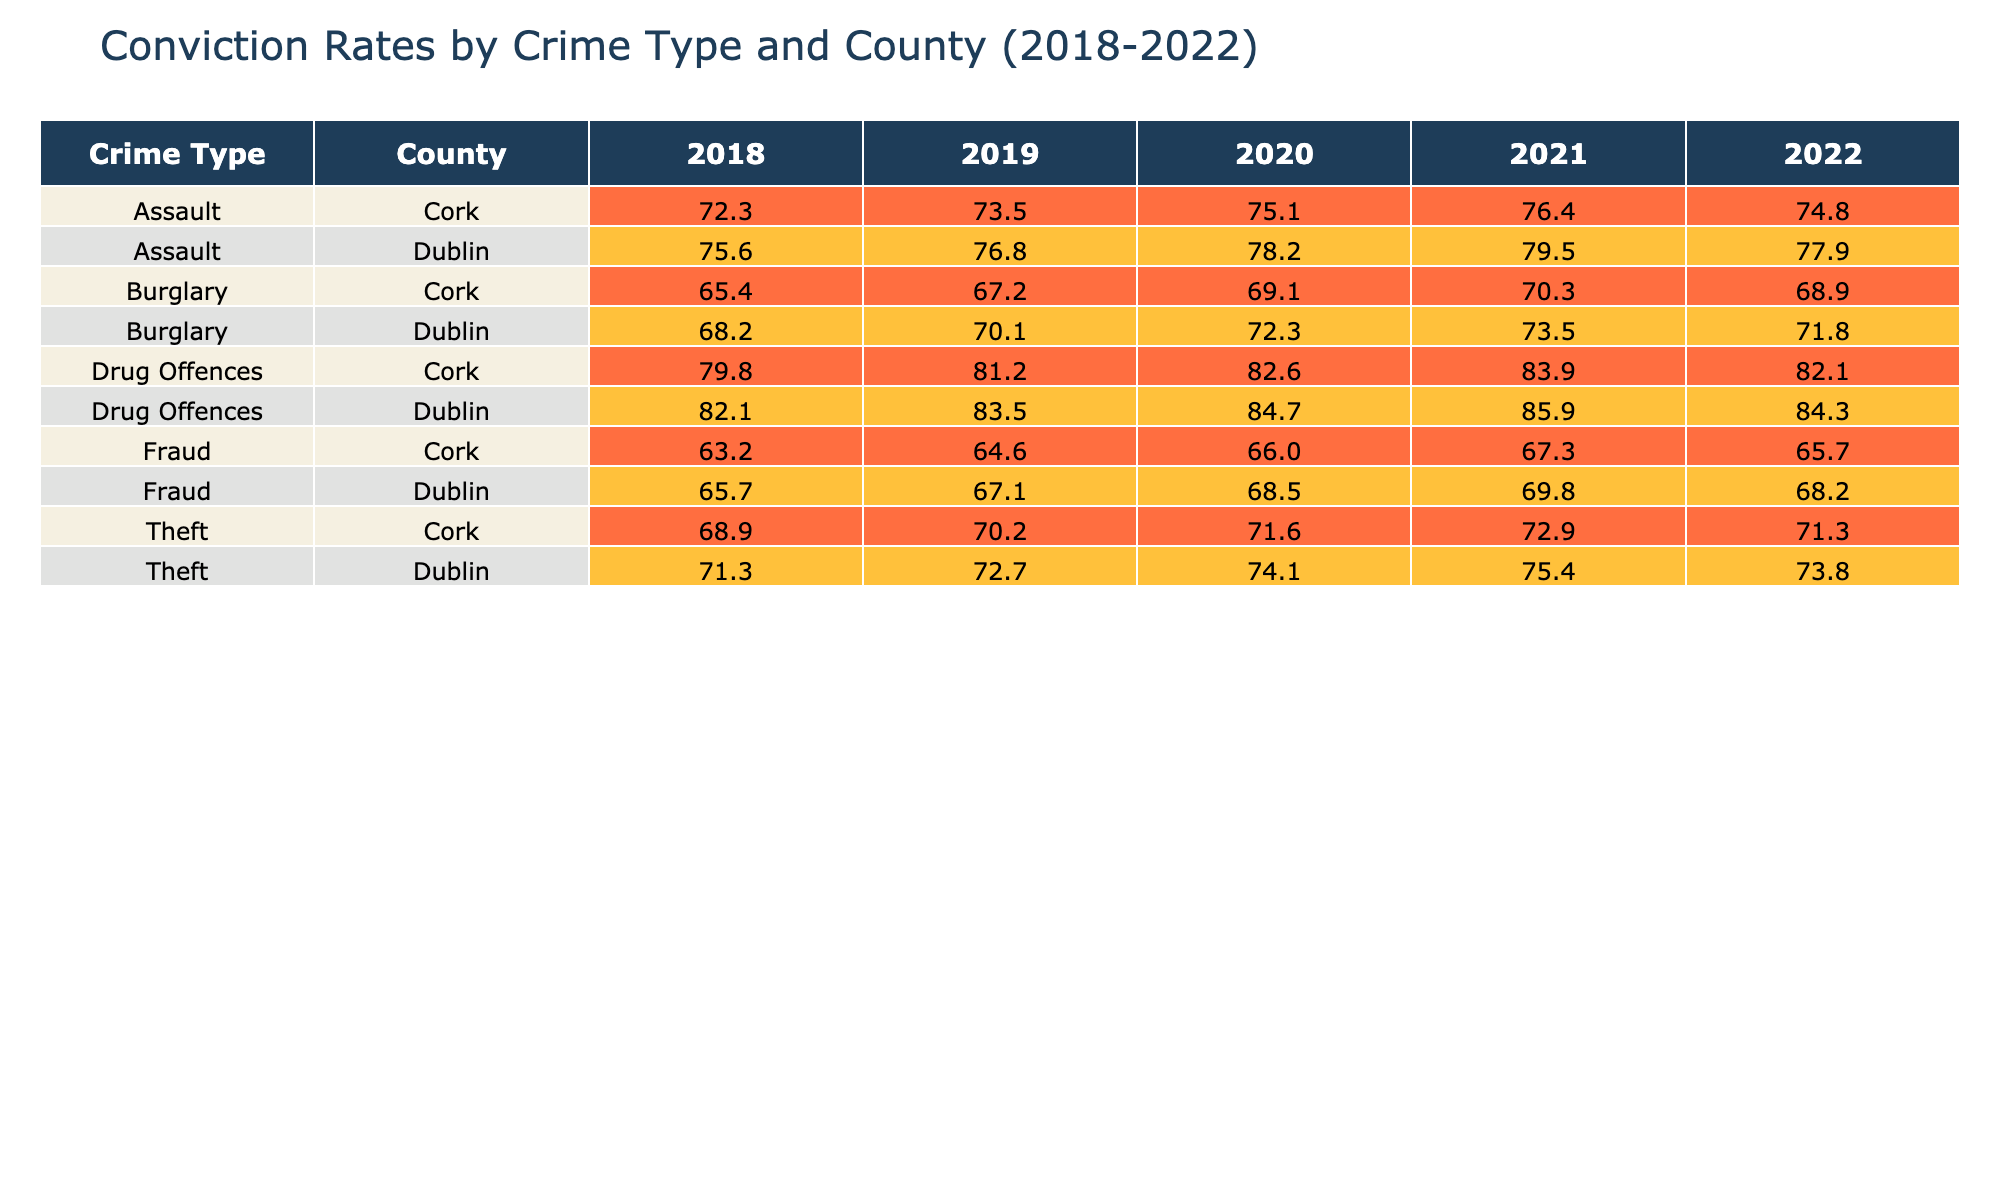What was the highest conviction rate for Burglary in Dublin? The conviction rates for Burglary in Dublin over the years are 68.2%, 70.1%, 72.3%, 73.5%, and 71.8%. The highest among these values is 73.5%, which occurred in 2021.
Answer: 73.5 What is the average conviction rate for Drug Offences in Cork across the five years? The conviction rates for Drug Offences in Cork are 79.8%, 81.2%, 82.6%, 83.9%, and 82.1%. Adding these gives a total of 409.6%. Dividing by 5 yields an average of 81.92%.
Answer: 81.92 Did Dublin have a higher conviction rate for Assault compared to Cork in 2021? In 2021, Dublin's conviction rate for Assault was 79.5%, while Cork's was 76.4%. Since 79.5% is greater than 76.4%, the statement is true.
Answer: Yes Was there a year when the conviction rate for Theft in Cork was lower than in Dublin? Comparing the conviction rates for Theft: In Cork the rates were 68.9%, 70.2%, 71.6%, 72.9%, and 71.3%. In Dublin, they were 71.3%, 72.7%, 74.1%, 75.4%, and 73.8%. There were multiple years (2018, 2019, 2020) when Cork's rates were lower.
Answer: Yes What was the difference in conviction rates for Drug Offences between Dublin and Cork in 2020? In 2020, Dublin's conviction rate for Drug Offences was 84.7% and Cork's was 82.6%. The difference is 84.7% - 82.6% = 2.1%.
Answer: 2.1 Which crime type had the lowest overall conviction rate in Cork for the year 2022? The conviction rates for Cork in 2022 were: Burglary 68.9%, Assault 74.8%, Drug Offences 82.1%, Theft 71.3%, and Fraud 65.7%. The lowest rate among these is 65.7%, corresponding to Fraud.
Answer: 65.7 How did the conviction rate for Fraud in Dublin change from 2018 to 2022? The rates for Fraud in Dublin from 2018 to 2022 are 65.7%, 67.1%, 68.5%, 69.8%, and 68.2%. The change is from 65.7% to 68.2%, which is an increase of 2.5%.
Answer: Increased by 2.5 What is the conviction rate trend for Assault in Dublin over the past five years? The conviction rates for Assault in Dublin are 75.6%, 76.8%, 78.2%, 79.5%, and 77.9%. The rates generally increased until 2021, but then decreased in 2022.
Answer: Increased then decreased Were the conviction rates for Theft in Dublin consistently higher than those in Cork from 2018 to 2022? Checking year by year: 2018 (Dublin 71.3% > Cork 68.9%), 2019 (Dublin 72.7% > Cork 70.2%), 2020 (Dublin 74.1% > Cork 71.6%), 2021 (Dublin 75.4% > Cork 72.9%), 2022 (Dublin 73.8% > Cork 71.3%). Thus, Dublin had higher rates every year.
Answer: Yes 